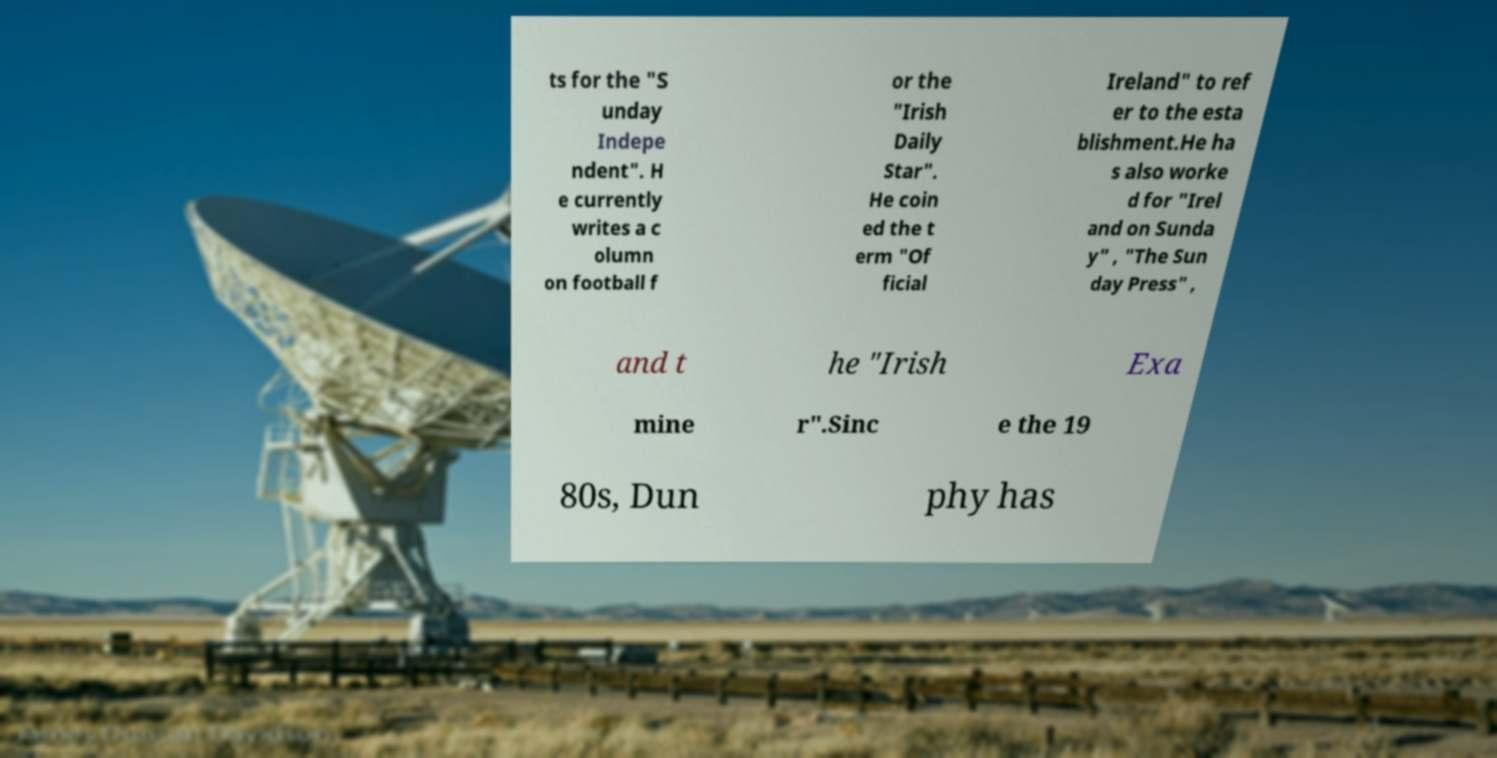For documentation purposes, I need the text within this image transcribed. Could you provide that? ts for the "S unday Indepe ndent". H e currently writes a c olumn on football f or the "Irish Daily Star". He coin ed the t erm "Of ficial Ireland" to ref er to the esta blishment.He ha s also worke d for "Irel and on Sunda y" , "The Sun day Press" , and t he "Irish Exa mine r".Sinc e the 19 80s, Dun phy has 